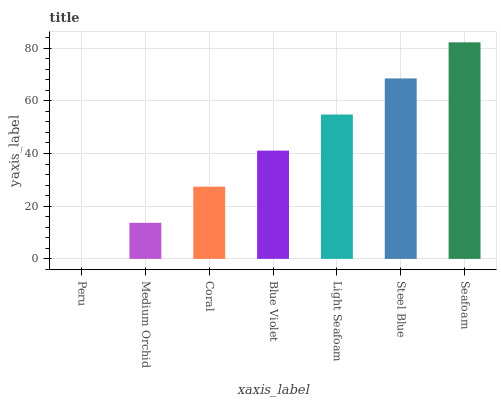Is Peru the minimum?
Answer yes or no. Yes. Is Seafoam the maximum?
Answer yes or no. Yes. Is Medium Orchid the minimum?
Answer yes or no. No. Is Medium Orchid the maximum?
Answer yes or no. No. Is Medium Orchid greater than Peru?
Answer yes or no. Yes. Is Peru less than Medium Orchid?
Answer yes or no. Yes. Is Peru greater than Medium Orchid?
Answer yes or no. No. Is Medium Orchid less than Peru?
Answer yes or no. No. Is Blue Violet the high median?
Answer yes or no. Yes. Is Blue Violet the low median?
Answer yes or no. Yes. Is Peru the high median?
Answer yes or no. No. Is Light Seafoam the low median?
Answer yes or no. No. 